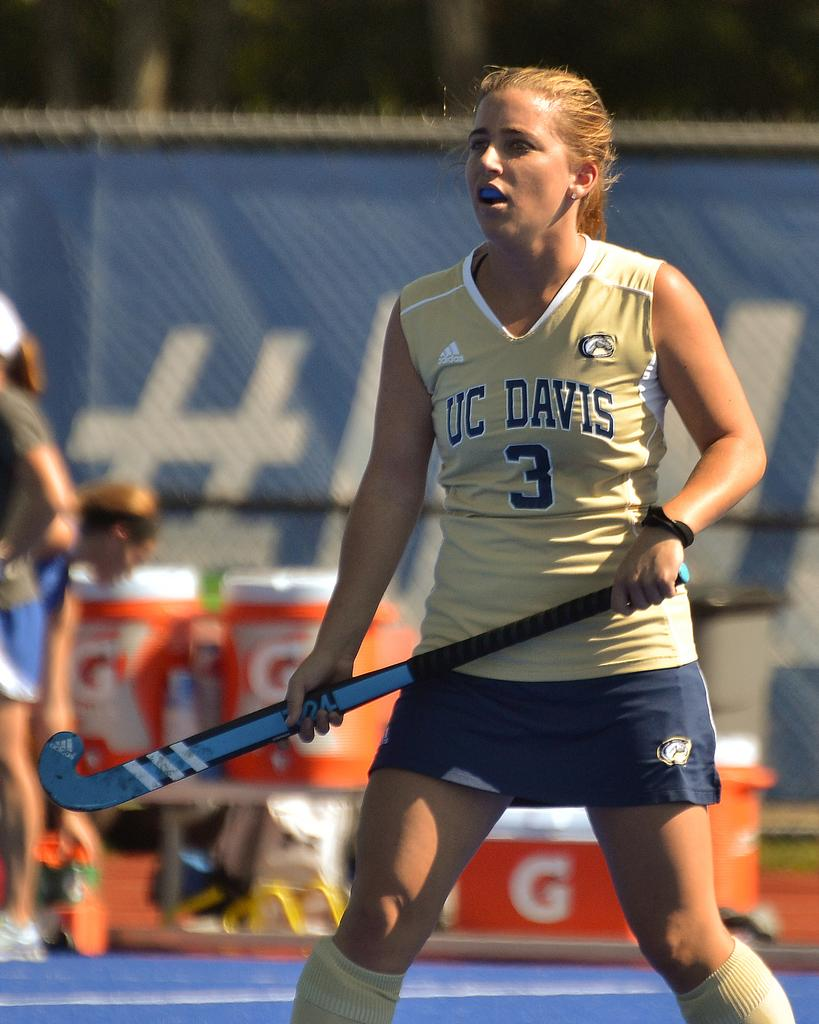Provide a one-sentence caption for the provided image. a young white teen playing a sport holding a stick. 